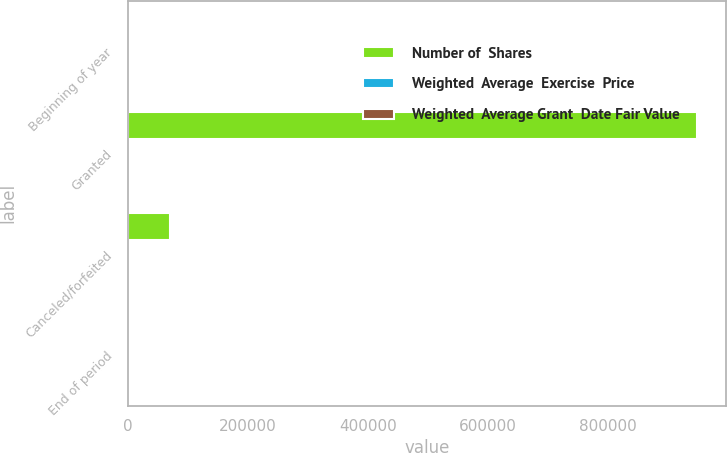Convert chart. <chart><loc_0><loc_0><loc_500><loc_500><stacked_bar_chart><ecel><fcel>Beginning of year<fcel>Granted<fcel>Canceled/forfeited<fcel>End of period<nl><fcel>Number of  Shares<fcel>29.375<fcel>949200<fcel>69800<fcel>29.375<nl><fcel>Weighted  Average  Exercise  Price<fcel>26.69<fcel>49.32<fcel>44.2<fcel>32.06<nl><fcel>Weighted  Average Grant  Date Fair Value<fcel>10.27<fcel>11.22<fcel>10.7<fcel>10.88<nl></chart> 